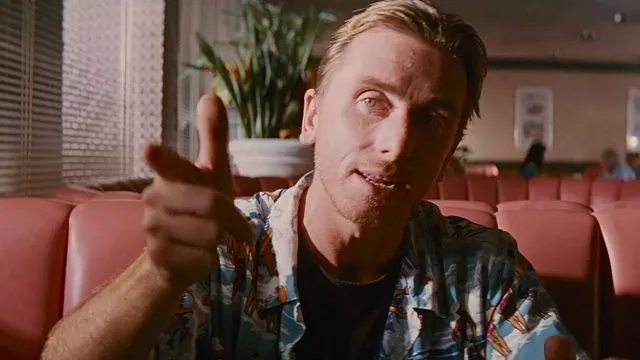What kind of atmosphere does the interior setting of this image convey? The blurred background with visible booth seating and a plant suggests a calm and casual atmosphere, typical of a diner or cafe designed for comfort and informal dining. The soft lighting contributes to a sense of ease and accessibility within the space. 